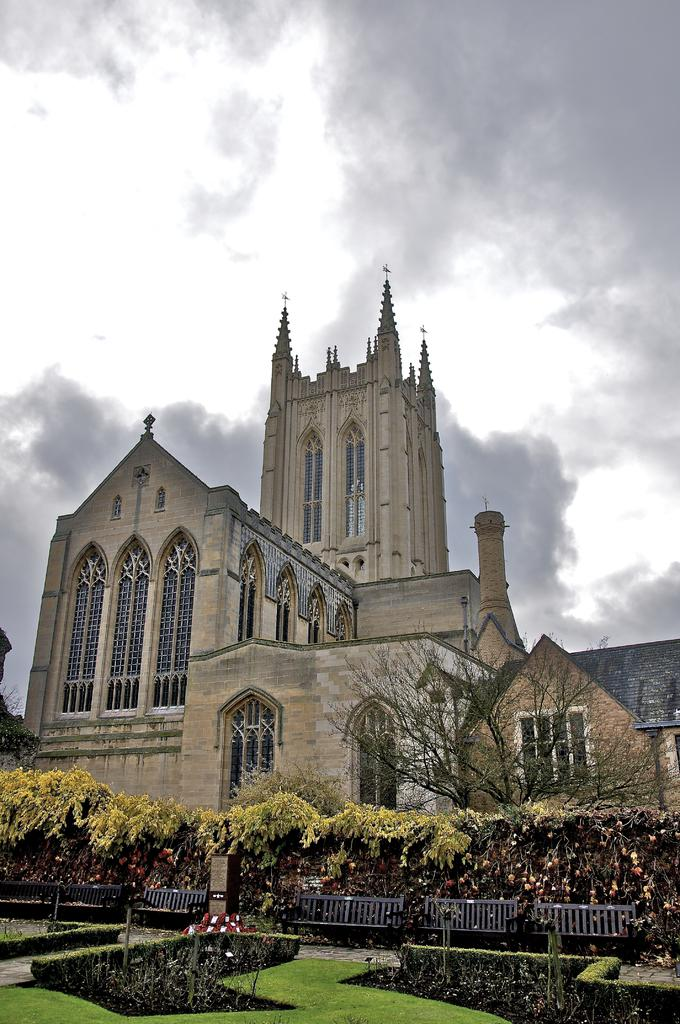What type of vegetation is present on the ground in the image? There are plants on the ground in the image. What else is present on the ground besides plants? There is grass on the ground in the image. What can be seen in the background of the image? There are buildings in the background of the image. What features do the buildings have? The buildings have windows and roofs. What is visible in the sky in the image? There are clouds in the sky in the image. What type of butter is being used to hold the wire in place in the image? There is no butter or wire present in the image. What time is displayed on the watch in the image? There is no watch present in the image. 